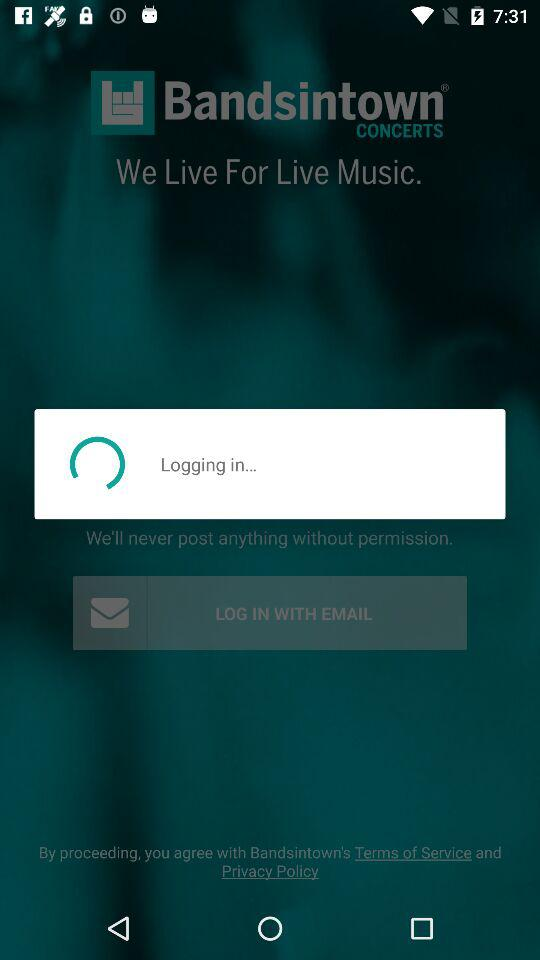Which bands are currently in town?
When the provided information is insufficient, respond with <no answer>. <no answer> 